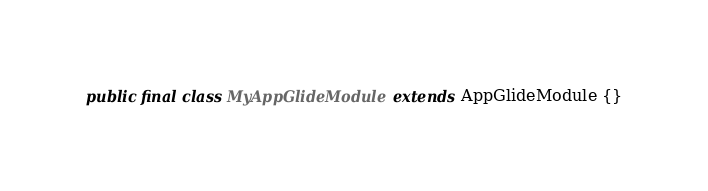<code> <loc_0><loc_0><loc_500><loc_500><_Java_>public final class MyAppGlideModule extends AppGlideModule {}

</code> 